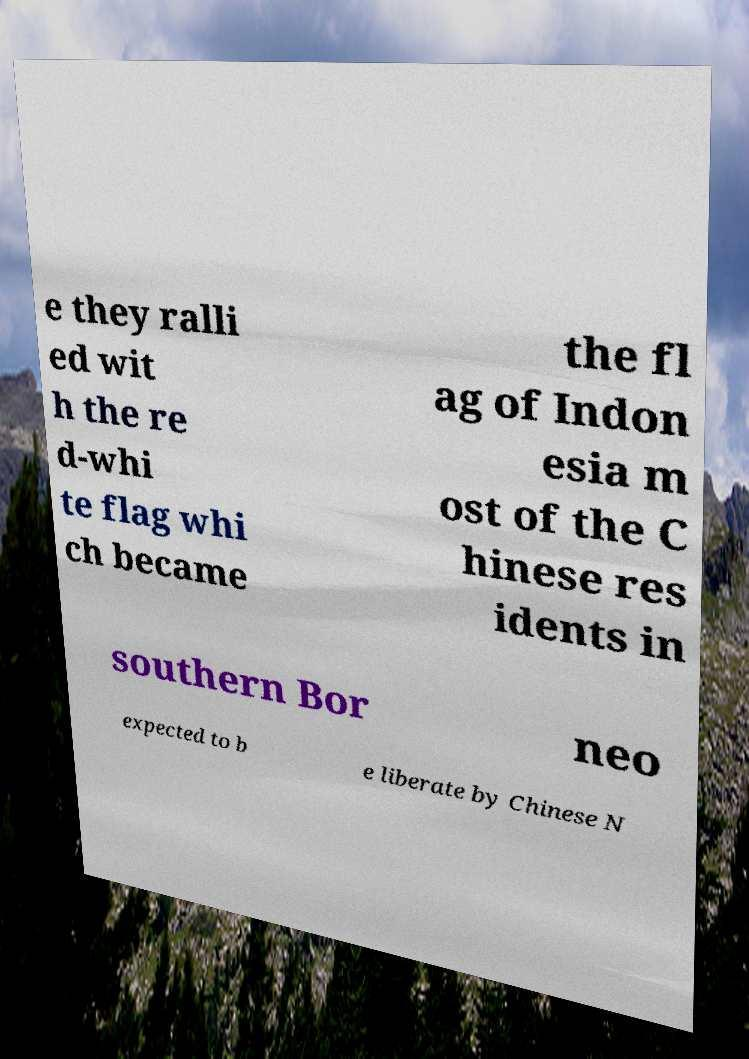For documentation purposes, I need the text within this image transcribed. Could you provide that? e they ralli ed wit h the re d-whi te flag whi ch became the fl ag of Indon esia m ost of the C hinese res idents in southern Bor neo expected to b e liberate by Chinese N 